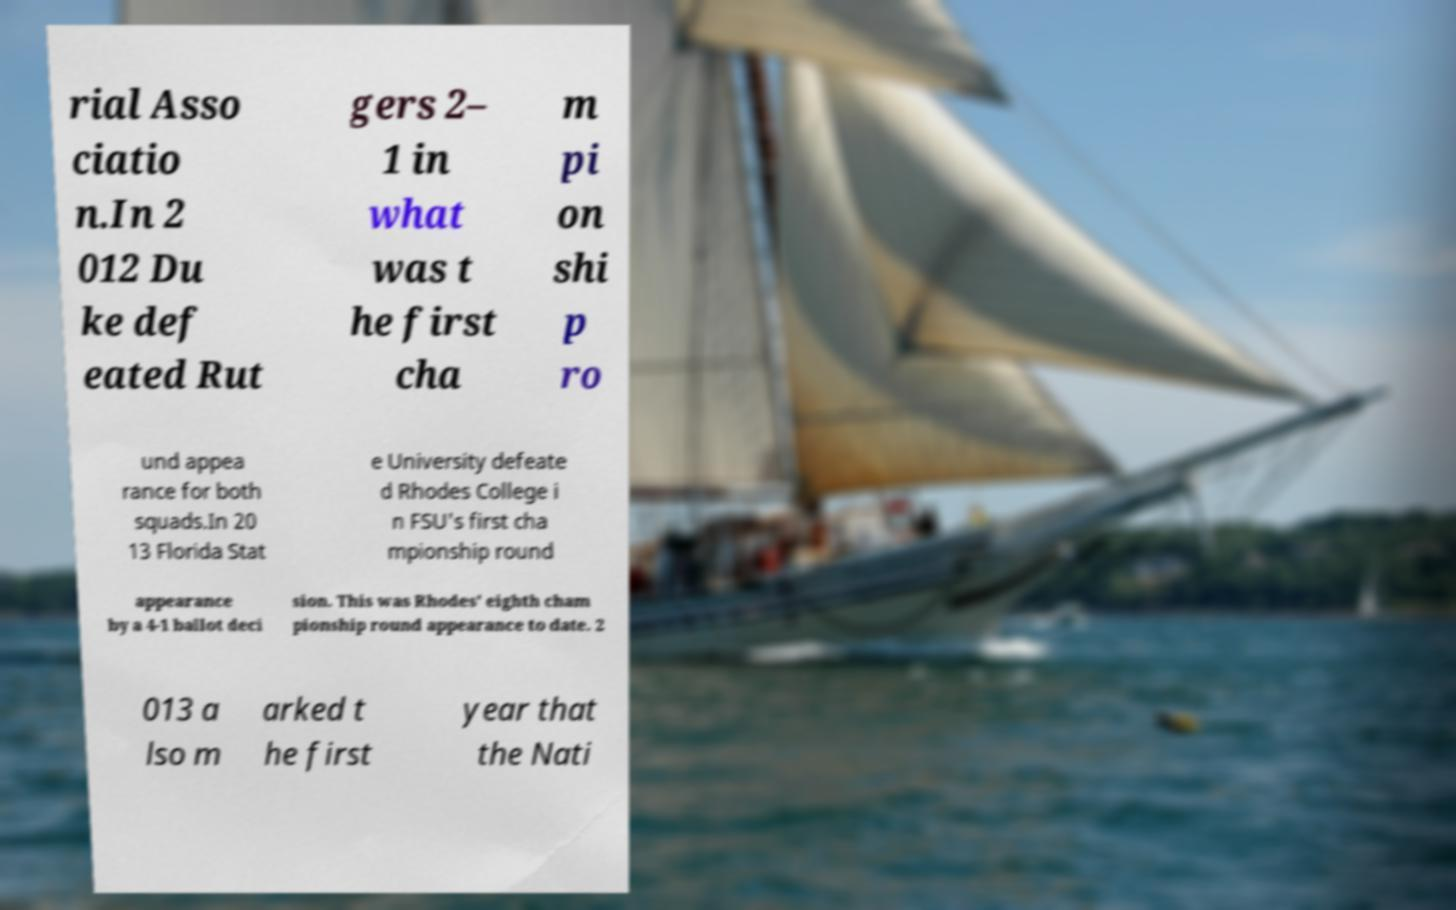Could you assist in decoding the text presented in this image and type it out clearly? rial Asso ciatio n.In 2 012 Du ke def eated Rut gers 2– 1 in what was t he first cha m pi on shi p ro und appea rance for both squads.In 20 13 Florida Stat e University defeate d Rhodes College i n FSU's first cha mpionship round appearance by a 4-1 ballot deci sion. This was Rhodes' eighth cham pionship round appearance to date. 2 013 a lso m arked t he first year that the Nati 